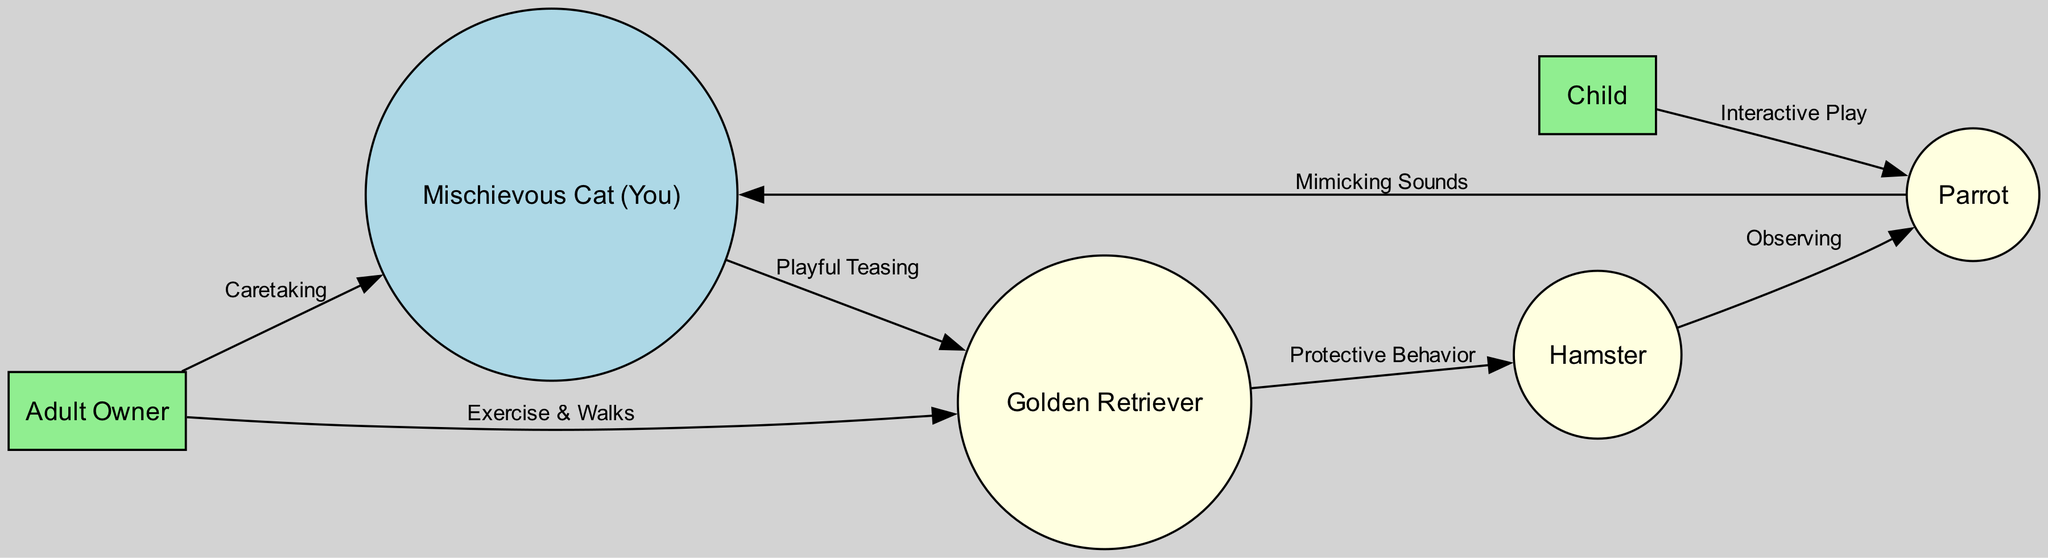What is the central figure in the diagram? The central figure is the "Mischievous Cat (You)", as it is represented at the center of the network of relationships and interactions among the pets and humans.
Answer: Mischievous Cat (You) How many nodes represent pets in the diagram? There are four nodes that represent pets: "Mischievous Cat (You)", "Golden Retriever", "Parrot", and "Hamster". This can be counted directly from the list of nodes in the data provided.
Answer: 4 What type of relationship exists between the Mischievous Cat and the Golden Retriever? The relationship is labeled "Playful Teasing", indicating that the mischievous cat often teases the calm golden retriever, thereby creating playful dynamics.
Answer: Playful Teasing Which pet observes another pet with curiosity? The "Hamster" observes the "Parrot" with curiosity, as indicated by the edge connecting these two pets and the description of their interaction.
Answer: Hamster Who is responsible for taking the dog for walks? The responsible party for taking the dog for walks is the "Adult Owner", who is indicated as the primary caregiver for the pets and manages their care.
Answer: Adult Owner What action does the child engage in with the parrot? The child engages in "Interactive Play" with the parrot, showcasing the dynamic between the child and the lively bird through play and conversation.
Answer: Interactive Play Which pet is often guarded by the dog? The "Hamster" is often guarded by the "Golden Retriever", which signifies a protective dynamic between these two pets within the household.
Answer: Hamster What behavior does the parrot exhibit towards the mischievous cat? The parrot exhibits "Mimicking Sounds" towards the mischievous cat, reflecting the parrot’s tendency to imitate the noises made by the cat, which adds to the chaos and entertainment level in the household.
Answer: Mimicking Sounds 